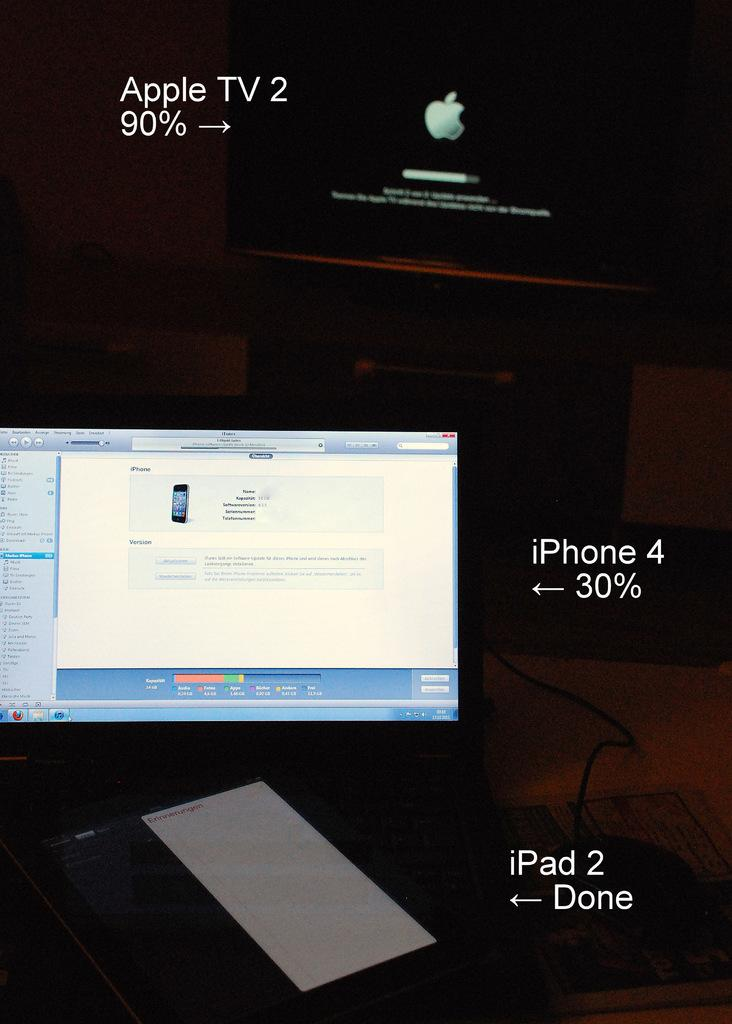<image>
Share a concise interpretation of the image provided. Laptop and a computer with a iphone 4 and ipad 2 connected to it 